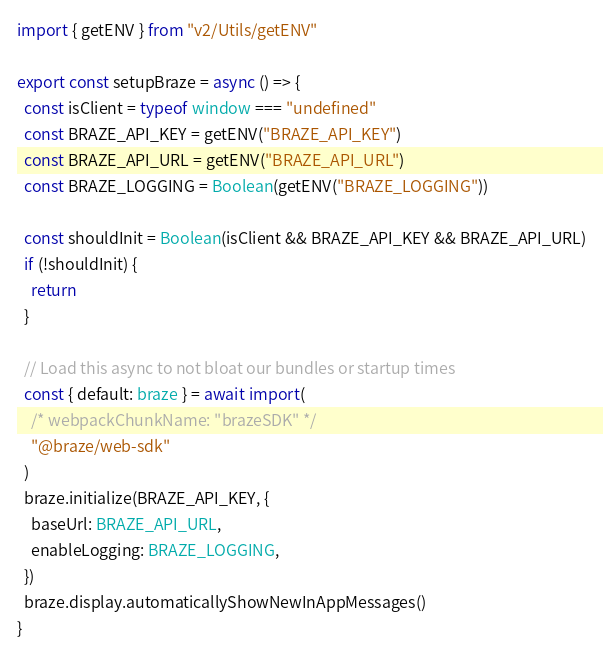Convert code to text. <code><loc_0><loc_0><loc_500><loc_500><_TypeScript_>import { getENV } from "v2/Utils/getENV"

export const setupBraze = async () => {
  const isClient = typeof window === "undefined"
  const BRAZE_API_KEY = getENV("BRAZE_API_KEY")
  const BRAZE_API_URL = getENV("BRAZE_API_URL")
  const BRAZE_LOGGING = Boolean(getENV("BRAZE_LOGGING"))

  const shouldInit = Boolean(isClient && BRAZE_API_KEY && BRAZE_API_URL)
  if (!shouldInit) {
    return
  }

  // Load this async to not bloat our bundles or startup times
  const { default: braze } = await import(
    /* webpackChunkName: "brazeSDK" */
    "@braze/web-sdk"
  )
  braze.initialize(BRAZE_API_KEY, {
    baseUrl: BRAZE_API_URL,
    enableLogging: BRAZE_LOGGING,
  })
  braze.display.automaticallyShowNewInAppMessages()
}
</code> 